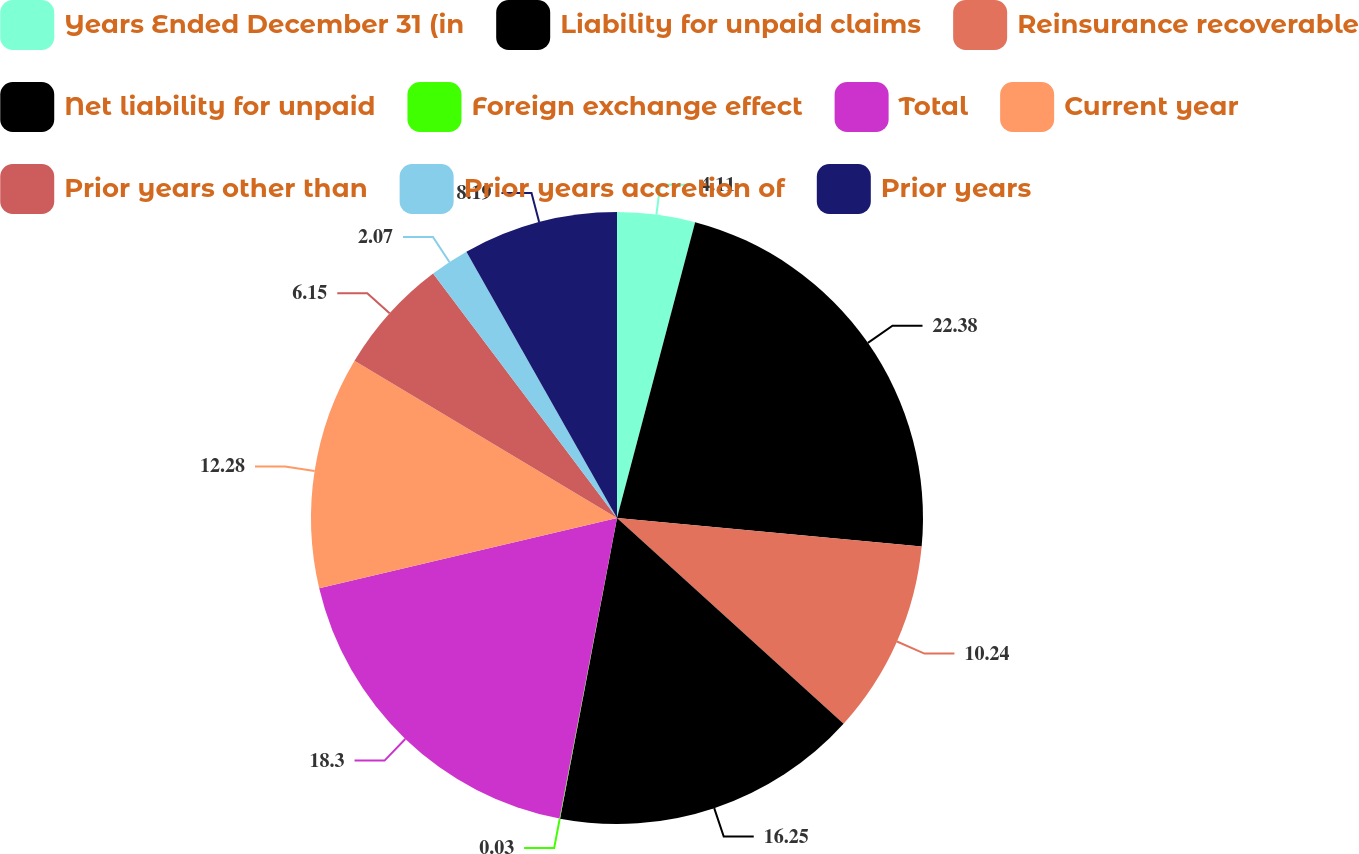Convert chart to OTSL. <chart><loc_0><loc_0><loc_500><loc_500><pie_chart><fcel>Years Ended December 31 (in<fcel>Liability for unpaid claims<fcel>Reinsurance recoverable<fcel>Net liability for unpaid<fcel>Foreign exchange effect<fcel>Total<fcel>Current year<fcel>Prior years other than<fcel>Prior years accretion of<fcel>Prior years<nl><fcel>4.11%<fcel>22.38%<fcel>10.24%<fcel>16.25%<fcel>0.03%<fcel>18.3%<fcel>12.28%<fcel>6.15%<fcel>2.07%<fcel>8.19%<nl></chart> 